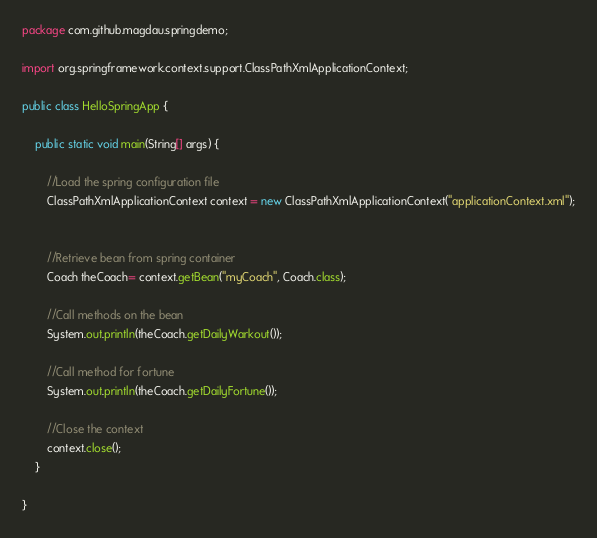Convert code to text. <code><loc_0><loc_0><loc_500><loc_500><_Java_>package com.github.magdau.springdemo;

import org.springframework.context.support.ClassPathXmlApplicationContext;

public class HelloSpringApp {

	public static void main(String[] args) {
		
		//Load the spring configuration file
		ClassPathXmlApplicationContext context = new ClassPathXmlApplicationContext("applicationContext.xml");
		
	
		//Retrieve bean from spring container
		Coach theCoach= context.getBean("myCoach", Coach.class);
		
		//Call methods on the bean
		System.out.println(theCoach.getDailyWarkout()); 
		
		//Call method for fortune
		System.out.println(theCoach.getDailyFortune());
			
		//Close the context
		context.close();
	}

}
</code> 